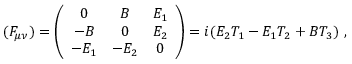<formula> <loc_0><loc_0><loc_500><loc_500>( F _ { \mu \nu } ) = \left ( \begin{array} { c c c } { 0 } & { B } & { { E _ { 1 } } } \\ { - B } & { 0 } & { { E _ { 2 } } } \\ { { - E _ { 1 } } } & { { - E _ { 2 } } } & { 0 } \end{array} \right ) = i ( E _ { 2 } T _ { 1 } - E _ { 1 } T _ { 2 } + B T _ { 3 } ) \ ,</formula> 